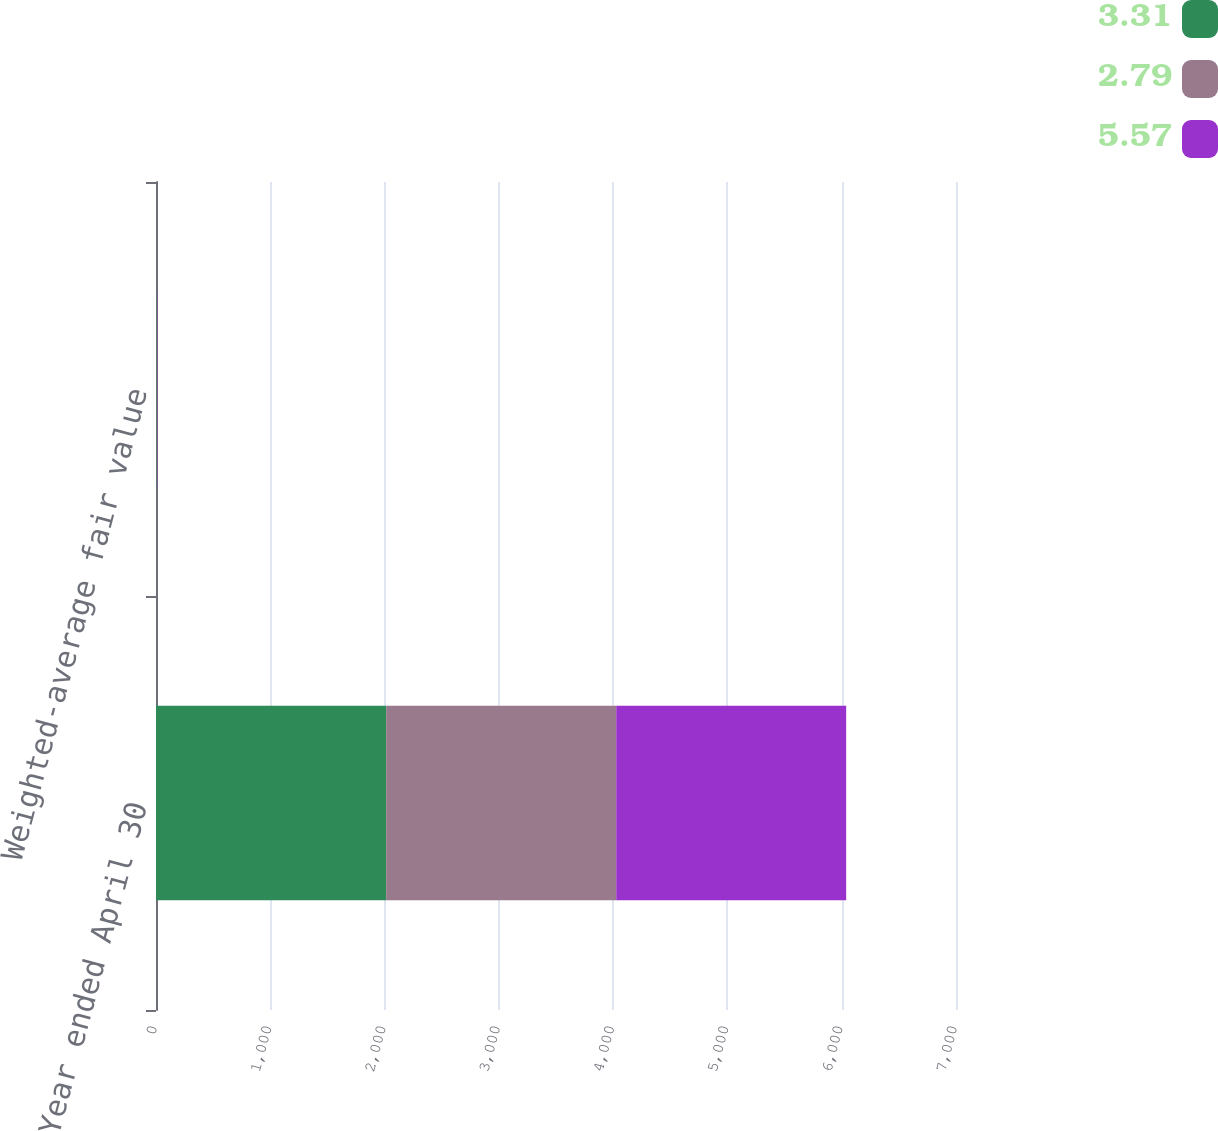Convert chart to OTSL. <chart><loc_0><loc_0><loc_500><loc_500><stacked_bar_chart><ecel><fcel>Year ended April 30<fcel>Weighted-average fair value<nl><fcel>3.31<fcel>2014<fcel>5.57<nl><fcel>2.79<fcel>2013<fcel>2.79<nl><fcel>5.57<fcel>2012<fcel>3.31<nl></chart> 